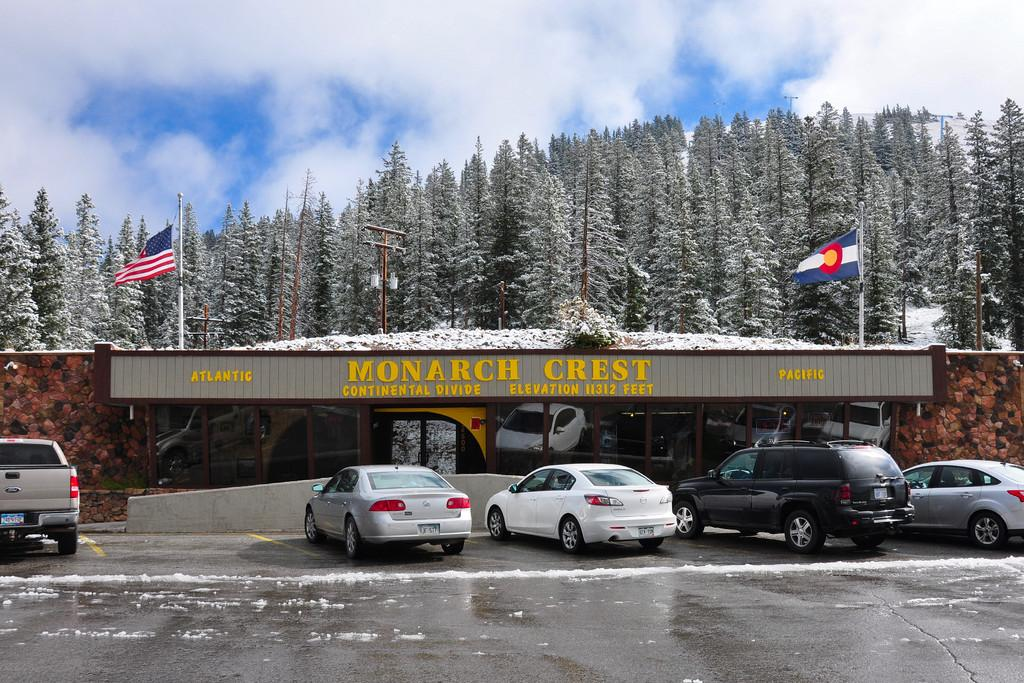What can be seen on the road in the image? There are fleets of cars on the road in the image. What structure is present in the image? There is a shed in the image. What can be seen in the background of the image? There are flags, trees, concrete, and the sky visible in the background of the image. Can you describe the weather condition in the image? The image may have been taken during a rainy day, as suggested by the presence of fleets of cars on the road. How many caps are visible on the cars in the image? There is no mention of caps on the cars in the image, so it is not possible to determine the number of caps. What type of number is written on the flags in the image? There is no mention of numbers on the flags in the image, so it is not possible to determine the type of number. 